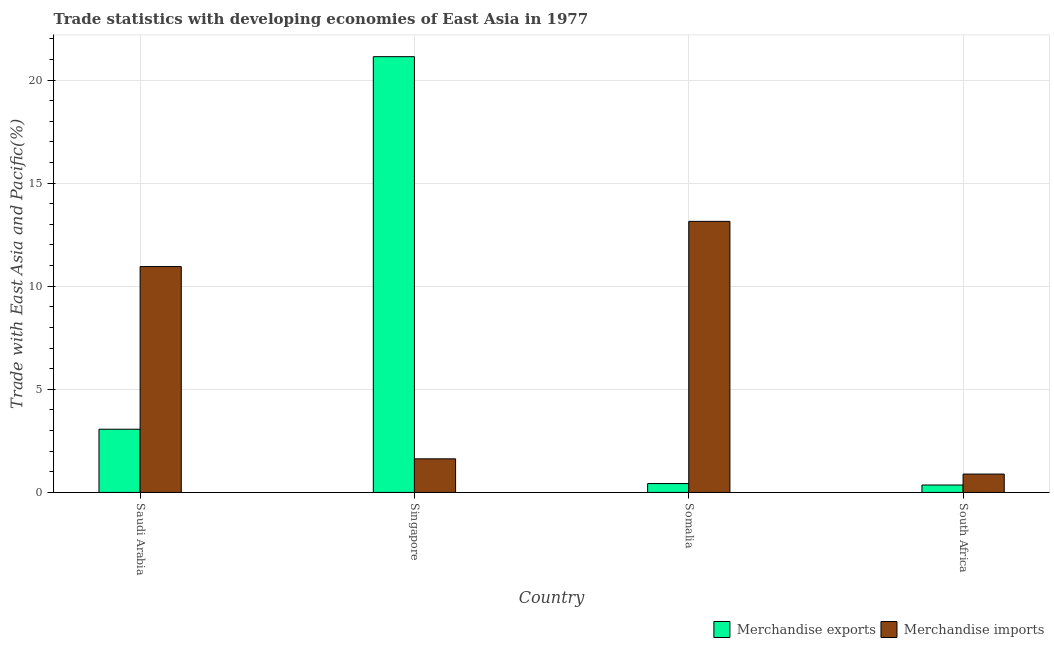How many groups of bars are there?
Provide a succinct answer. 4. Are the number of bars per tick equal to the number of legend labels?
Provide a short and direct response. Yes. Are the number of bars on each tick of the X-axis equal?
Your response must be concise. Yes. How many bars are there on the 3rd tick from the left?
Ensure brevity in your answer.  2. How many bars are there on the 2nd tick from the right?
Provide a succinct answer. 2. What is the label of the 4th group of bars from the left?
Offer a very short reply. South Africa. What is the merchandise imports in Saudi Arabia?
Your answer should be very brief. 10.95. Across all countries, what is the maximum merchandise imports?
Provide a succinct answer. 13.15. Across all countries, what is the minimum merchandise exports?
Offer a terse response. 0.36. In which country was the merchandise exports maximum?
Offer a terse response. Singapore. In which country was the merchandise imports minimum?
Give a very brief answer. South Africa. What is the total merchandise imports in the graph?
Keep it short and to the point. 26.62. What is the difference between the merchandise exports in Singapore and that in Somalia?
Your answer should be very brief. 20.7. What is the difference between the merchandise exports in Singapore and the merchandise imports in Saudi Arabia?
Provide a short and direct response. 10.18. What is the average merchandise exports per country?
Your answer should be compact. 6.25. What is the difference between the merchandise imports and merchandise exports in South Africa?
Your response must be concise. 0.53. What is the ratio of the merchandise imports in Saudi Arabia to that in Singapore?
Keep it short and to the point. 6.72. Is the merchandise imports in Saudi Arabia less than that in Somalia?
Keep it short and to the point. Yes. What is the difference between the highest and the second highest merchandise exports?
Provide a short and direct response. 18.07. What is the difference between the highest and the lowest merchandise exports?
Offer a very short reply. 20.77. In how many countries, is the merchandise exports greater than the average merchandise exports taken over all countries?
Your answer should be compact. 1. Is the sum of the merchandise exports in Saudi Arabia and Somalia greater than the maximum merchandise imports across all countries?
Offer a very short reply. No. What does the 1st bar from the left in South Africa represents?
Provide a short and direct response. Merchandise exports. Does the graph contain grids?
Keep it short and to the point. Yes. Where does the legend appear in the graph?
Offer a terse response. Bottom right. How are the legend labels stacked?
Ensure brevity in your answer.  Horizontal. What is the title of the graph?
Offer a terse response. Trade statistics with developing economies of East Asia in 1977. Does "From human activities" appear as one of the legend labels in the graph?
Give a very brief answer. No. What is the label or title of the X-axis?
Offer a terse response. Country. What is the label or title of the Y-axis?
Your response must be concise. Trade with East Asia and Pacific(%). What is the Trade with East Asia and Pacific(%) in Merchandise exports in Saudi Arabia?
Your answer should be very brief. 3.07. What is the Trade with East Asia and Pacific(%) in Merchandise imports in Saudi Arabia?
Give a very brief answer. 10.95. What is the Trade with East Asia and Pacific(%) in Merchandise exports in Singapore?
Your response must be concise. 21.13. What is the Trade with East Asia and Pacific(%) in Merchandise imports in Singapore?
Your answer should be compact. 1.63. What is the Trade with East Asia and Pacific(%) of Merchandise exports in Somalia?
Provide a short and direct response. 0.43. What is the Trade with East Asia and Pacific(%) of Merchandise imports in Somalia?
Offer a terse response. 13.15. What is the Trade with East Asia and Pacific(%) in Merchandise exports in South Africa?
Keep it short and to the point. 0.36. What is the Trade with East Asia and Pacific(%) of Merchandise imports in South Africa?
Provide a short and direct response. 0.89. Across all countries, what is the maximum Trade with East Asia and Pacific(%) of Merchandise exports?
Offer a terse response. 21.13. Across all countries, what is the maximum Trade with East Asia and Pacific(%) in Merchandise imports?
Offer a very short reply. 13.15. Across all countries, what is the minimum Trade with East Asia and Pacific(%) of Merchandise exports?
Provide a succinct answer. 0.36. Across all countries, what is the minimum Trade with East Asia and Pacific(%) in Merchandise imports?
Keep it short and to the point. 0.89. What is the total Trade with East Asia and Pacific(%) of Merchandise exports in the graph?
Offer a very short reply. 24.99. What is the total Trade with East Asia and Pacific(%) in Merchandise imports in the graph?
Provide a short and direct response. 26.62. What is the difference between the Trade with East Asia and Pacific(%) of Merchandise exports in Saudi Arabia and that in Singapore?
Keep it short and to the point. -18.07. What is the difference between the Trade with East Asia and Pacific(%) in Merchandise imports in Saudi Arabia and that in Singapore?
Offer a terse response. 9.32. What is the difference between the Trade with East Asia and Pacific(%) in Merchandise exports in Saudi Arabia and that in Somalia?
Give a very brief answer. 2.63. What is the difference between the Trade with East Asia and Pacific(%) of Merchandise imports in Saudi Arabia and that in Somalia?
Your response must be concise. -2.19. What is the difference between the Trade with East Asia and Pacific(%) of Merchandise exports in Saudi Arabia and that in South Africa?
Your response must be concise. 2.71. What is the difference between the Trade with East Asia and Pacific(%) in Merchandise imports in Saudi Arabia and that in South Africa?
Your answer should be very brief. 10.06. What is the difference between the Trade with East Asia and Pacific(%) in Merchandise exports in Singapore and that in Somalia?
Give a very brief answer. 20.7. What is the difference between the Trade with East Asia and Pacific(%) in Merchandise imports in Singapore and that in Somalia?
Your response must be concise. -11.52. What is the difference between the Trade with East Asia and Pacific(%) in Merchandise exports in Singapore and that in South Africa?
Your answer should be compact. 20.77. What is the difference between the Trade with East Asia and Pacific(%) in Merchandise imports in Singapore and that in South Africa?
Provide a short and direct response. 0.74. What is the difference between the Trade with East Asia and Pacific(%) of Merchandise exports in Somalia and that in South Africa?
Provide a short and direct response. 0.07. What is the difference between the Trade with East Asia and Pacific(%) in Merchandise imports in Somalia and that in South Africa?
Provide a succinct answer. 12.25. What is the difference between the Trade with East Asia and Pacific(%) of Merchandise exports in Saudi Arabia and the Trade with East Asia and Pacific(%) of Merchandise imports in Singapore?
Offer a very short reply. 1.44. What is the difference between the Trade with East Asia and Pacific(%) of Merchandise exports in Saudi Arabia and the Trade with East Asia and Pacific(%) of Merchandise imports in Somalia?
Offer a terse response. -10.08. What is the difference between the Trade with East Asia and Pacific(%) in Merchandise exports in Saudi Arabia and the Trade with East Asia and Pacific(%) in Merchandise imports in South Africa?
Offer a terse response. 2.17. What is the difference between the Trade with East Asia and Pacific(%) of Merchandise exports in Singapore and the Trade with East Asia and Pacific(%) of Merchandise imports in Somalia?
Ensure brevity in your answer.  7.99. What is the difference between the Trade with East Asia and Pacific(%) in Merchandise exports in Singapore and the Trade with East Asia and Pacific(%) in Merchandise imports in South Africa?
Provide a succinct answer. 20.24. What is the difference between the Trade with East Asia and Pacific(%) of Merchandise exports in Somalia and the Trade with East Asia and Pacific(%) of Merchandise imports in South Africa?
Offer a very short reply. -0.46. What is the average Trade with East Asia and Pacific(%) of Merchandise exports per country?
Provide a short and direct response. 6.25. What is the average Trade with East Asia and Pacific(%) of Merchandise imports per country?
Offer a very short reply. 6.65. What is the difference between the Trade with East Asia and Pacific(%) of Merchandise exports and Trade with East Asia and Pacific(%) of Merchandise imports in Saudi Arabia?
Offer a terse response. -7.89. What is the difference between the Trade with East Asia and Pacific(%) in Merchandise exports and Trade with East Asia and Pacific(%) in Merchandise imports in Singapore?
Your answer should be very brief. 19.5. What is the difference between the Trade with East Asia and Pacific(%) in Merchandise exports and Trade with East Asia and Pacific(%) in Merchandise imports in Somalia?
Provide a succinct answer. -12.71. What is the difference between the Trade with East Asia and Pacific(%) of Merchandise exports and Trade with East Asia and Pacific(%) of Merchandise imports in South Africa?
Offer a very short reply. -0.53. What is the ratio of the Trade with East Asia and Pacific(%) in Merchandise exports in Saudi Arabia to that in Singapore?
Provide a succinct answer. 0.15. What is the ratio of the Trade with East Asia and Pacific(%) of Merchandise imports in Saudi Arabia to that in Singapore?
Your answer should be compact. 6.72. What is the ratio of the Trade with East Asia and Pacific(%) of Merchandise exports in Saudi Arabia to that in Somalia?
Provide a short and direct response. 7.12. What is the ratio of the Trade with East Asia and Pacific(%) in Merchandise imports in Saudi Arabia to that in Somalia?
Your response must be concise. 0.83. What is the ratio of the Trade with East Asia and Pacific(%) of Merchandise exports in Saudi Arabia to that in South Africa?
Make the answer very short. 8.51. What is the ratio of the Trade with East Asia and Pacific(%) in Merchandise imports in Saudi Arabia to that in South Africa?
Ensure brevity in your answer.  12.29. What is the ratio of the Trade with East Asia and Pacific(%) in Merchandise exports in Singapore to that in Somalia?
Ensure brevity in your answer.  49.1. What is the ratio of the Trade with East Asia and Pacific(%) in Merchandise imports in Singapore to that in Somalia?
Provide a short and direct response. 0.12. What is the ratio of the Trade with East Asia and Pacific(%) in Merchandise exports in Singapore to that in South Africa?
Give a very brief answer. 58.67. What is the ratio of the Trade with East Asia and Pacific(%) of Merchandise imports in Singapore to that in South Africa?
Keep it short and to the point. 1.83. What is the ratio of the Trade with East Asia and Pacific(%) of Merchandise exports in Somalia to that in South Africa?
Provide a succinct answer. 1.2. What is the ratio of the Trade with East Asia and Pacific(%) in Merchandise imports in Somalia to that in South Africa?
Provide a succinct answer. 14.76. What is the difference between the highest and the second highest Trade with East Asia and Pacific(%) in Merchandise exports?
Your answer should be compact. 18.07. What is the difference between the highest and the second highest Trade with East Asia and Pacific(%) in Merchandise imports?
Provide a succinct answer. 2.19. What is the difference between the highest and the lowest Trade with East Asia and Pacific(%) in Merchandise exports?
Your response must be concise. 20.77. What is the difference between the highest and the lowest Trade with East Asia and Pacific(%) in Merchandise imports?
Ensure brevity in your answer.  12.25. 